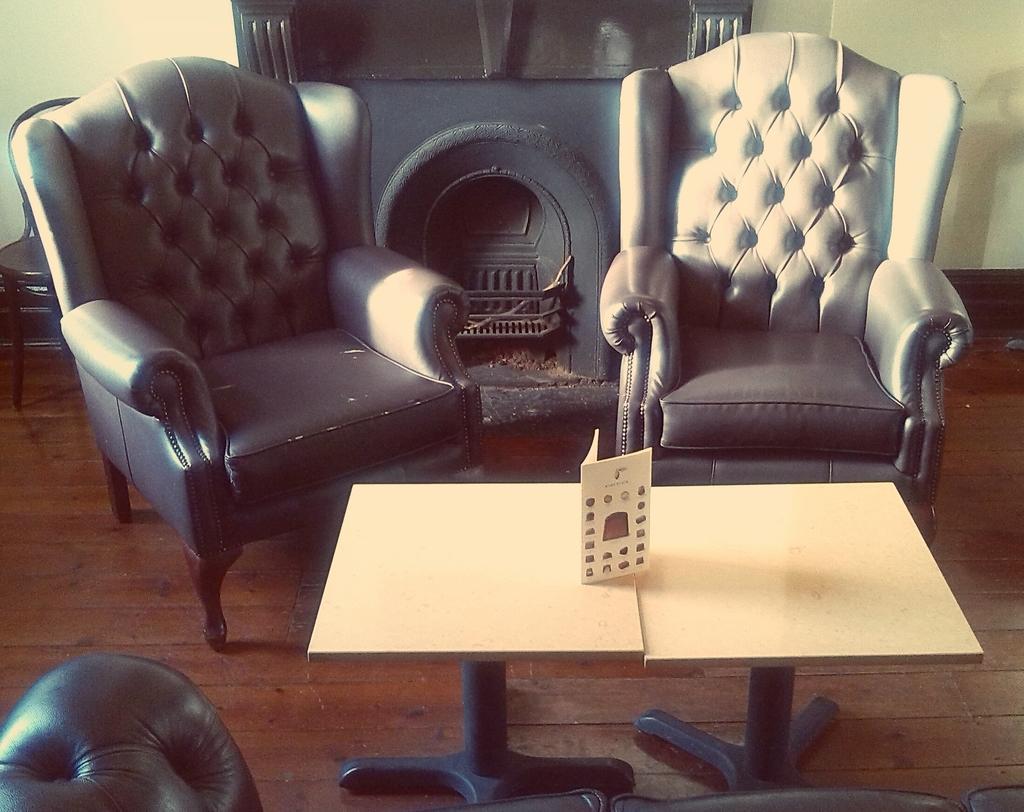Can you describe this image briefly? In this image there are chairs and we can see tables. There is a card placed on the tables. In the background we can see a fireplace and a wall. At the bottom we can see a couch. 